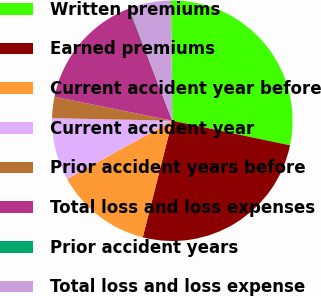Convert chart to OTSL. <chart><loc_0><loc_0><loc_500><loc_500><pie_chart><fcel>Written premiums<fcel>Earned premiums<fcel>Current accident year before<fcel>Current accident year<fcel>Prior accident years before<fcel>Total loss and loss expenses<fcel>Prior accident years<fcel>Total loss and loss expense<nl><fcel>28.45%<fcel>25.68%<fcel>12.99%<fcel>8.39%<fcel>2.86%<fcel>15.91%<fcel>0.09%<fcel>5.62%<nl></chart> 